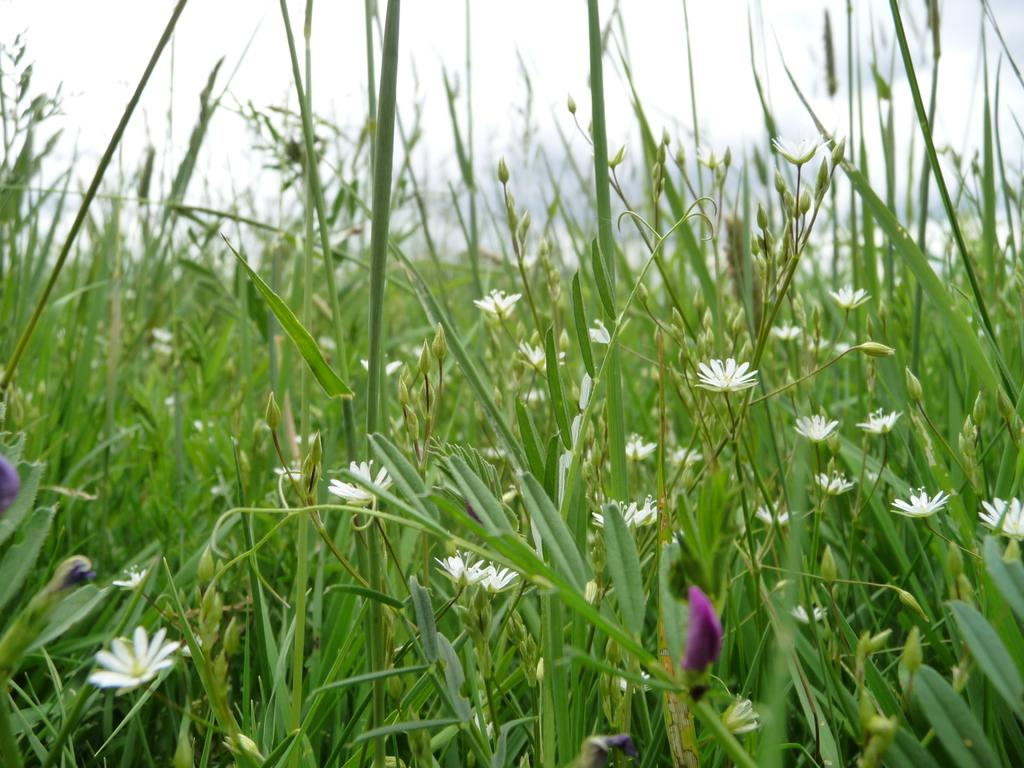What type of flowers can be seen in the image? There are white flowers in the image. What stage of growth are some of the flowers in? There are buds in the image. What part of the natural environment is visible in the image? The sky is visible at the top of the image, and there is grass visible in the background of the image. What type of fear can be seen in the image? There is no fear present in the image; it features white flowers and buds in a natural setting. How many windows are visible in the image? There are no windows visible in the image; it focuses on the flowers and natural setting. 